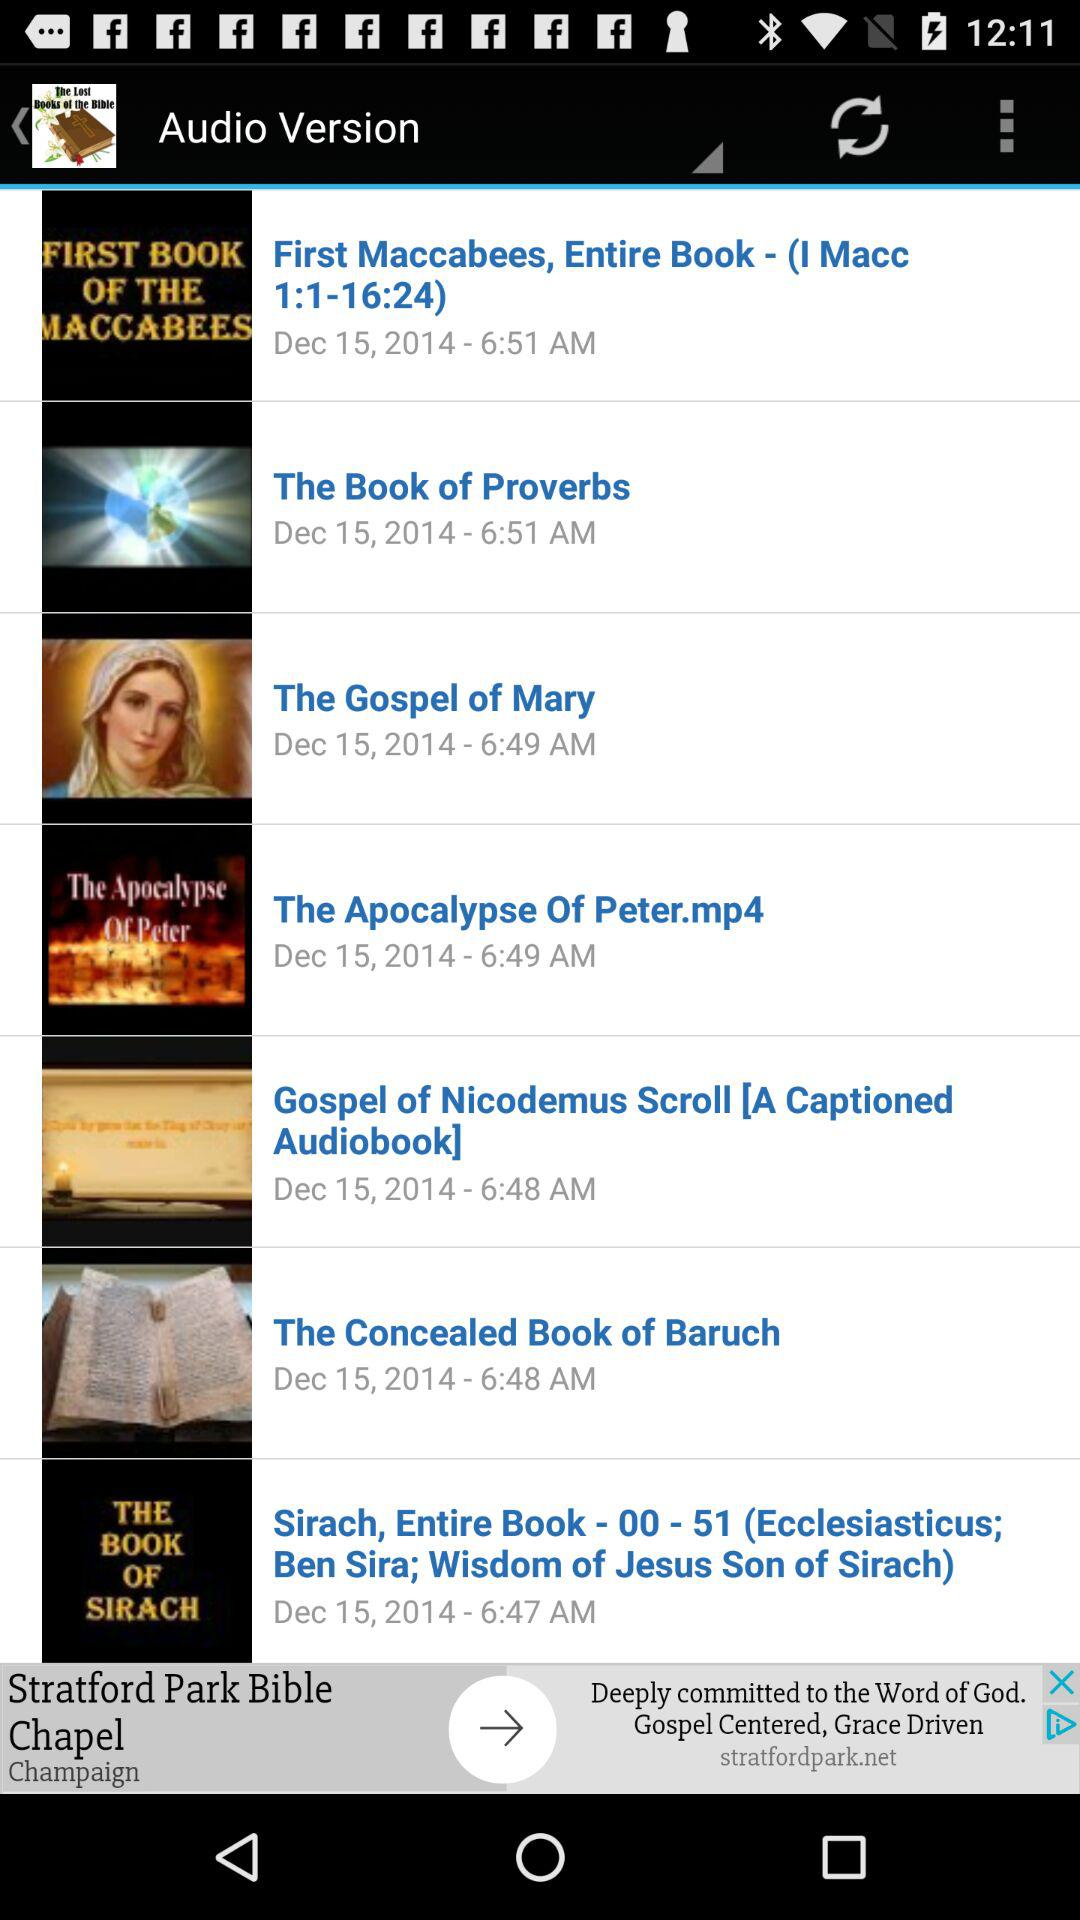What is the posting time of the "First Maccabees, Entire Book"? The posting time is 6:51 a.m. 